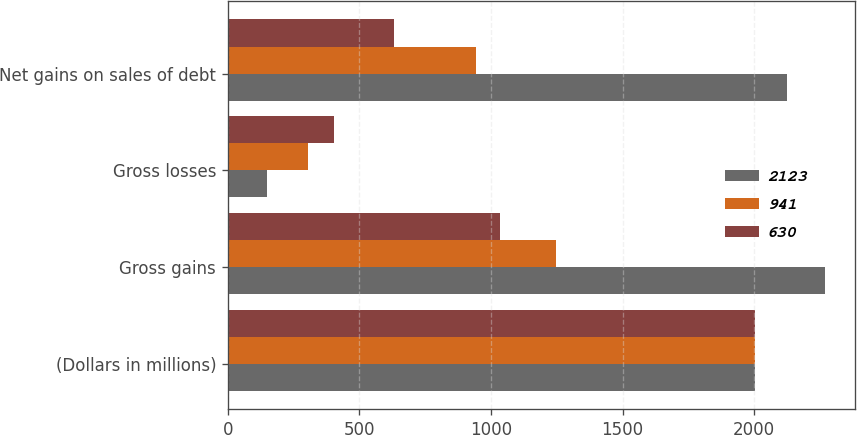Convert chart. <chart><loc_0><loc_0><loc_500><loc_500><stacked_bar_chart><ecel><fcel>(Dollars in millions)<fcel>Gross gains<fcel>Gross losses<fcel>Net gains on sales of debt<nl><fcel>2123<fcel>2004<fcel>2270<fcel>147<fcel>2123<nl><fcel>941<fcel>2003<fcel>1246<fcel>305<fcel>941<nl><fcel>630<fcel>2002<fcel>1035<fcel>405<fcel>630<nl></chart> 